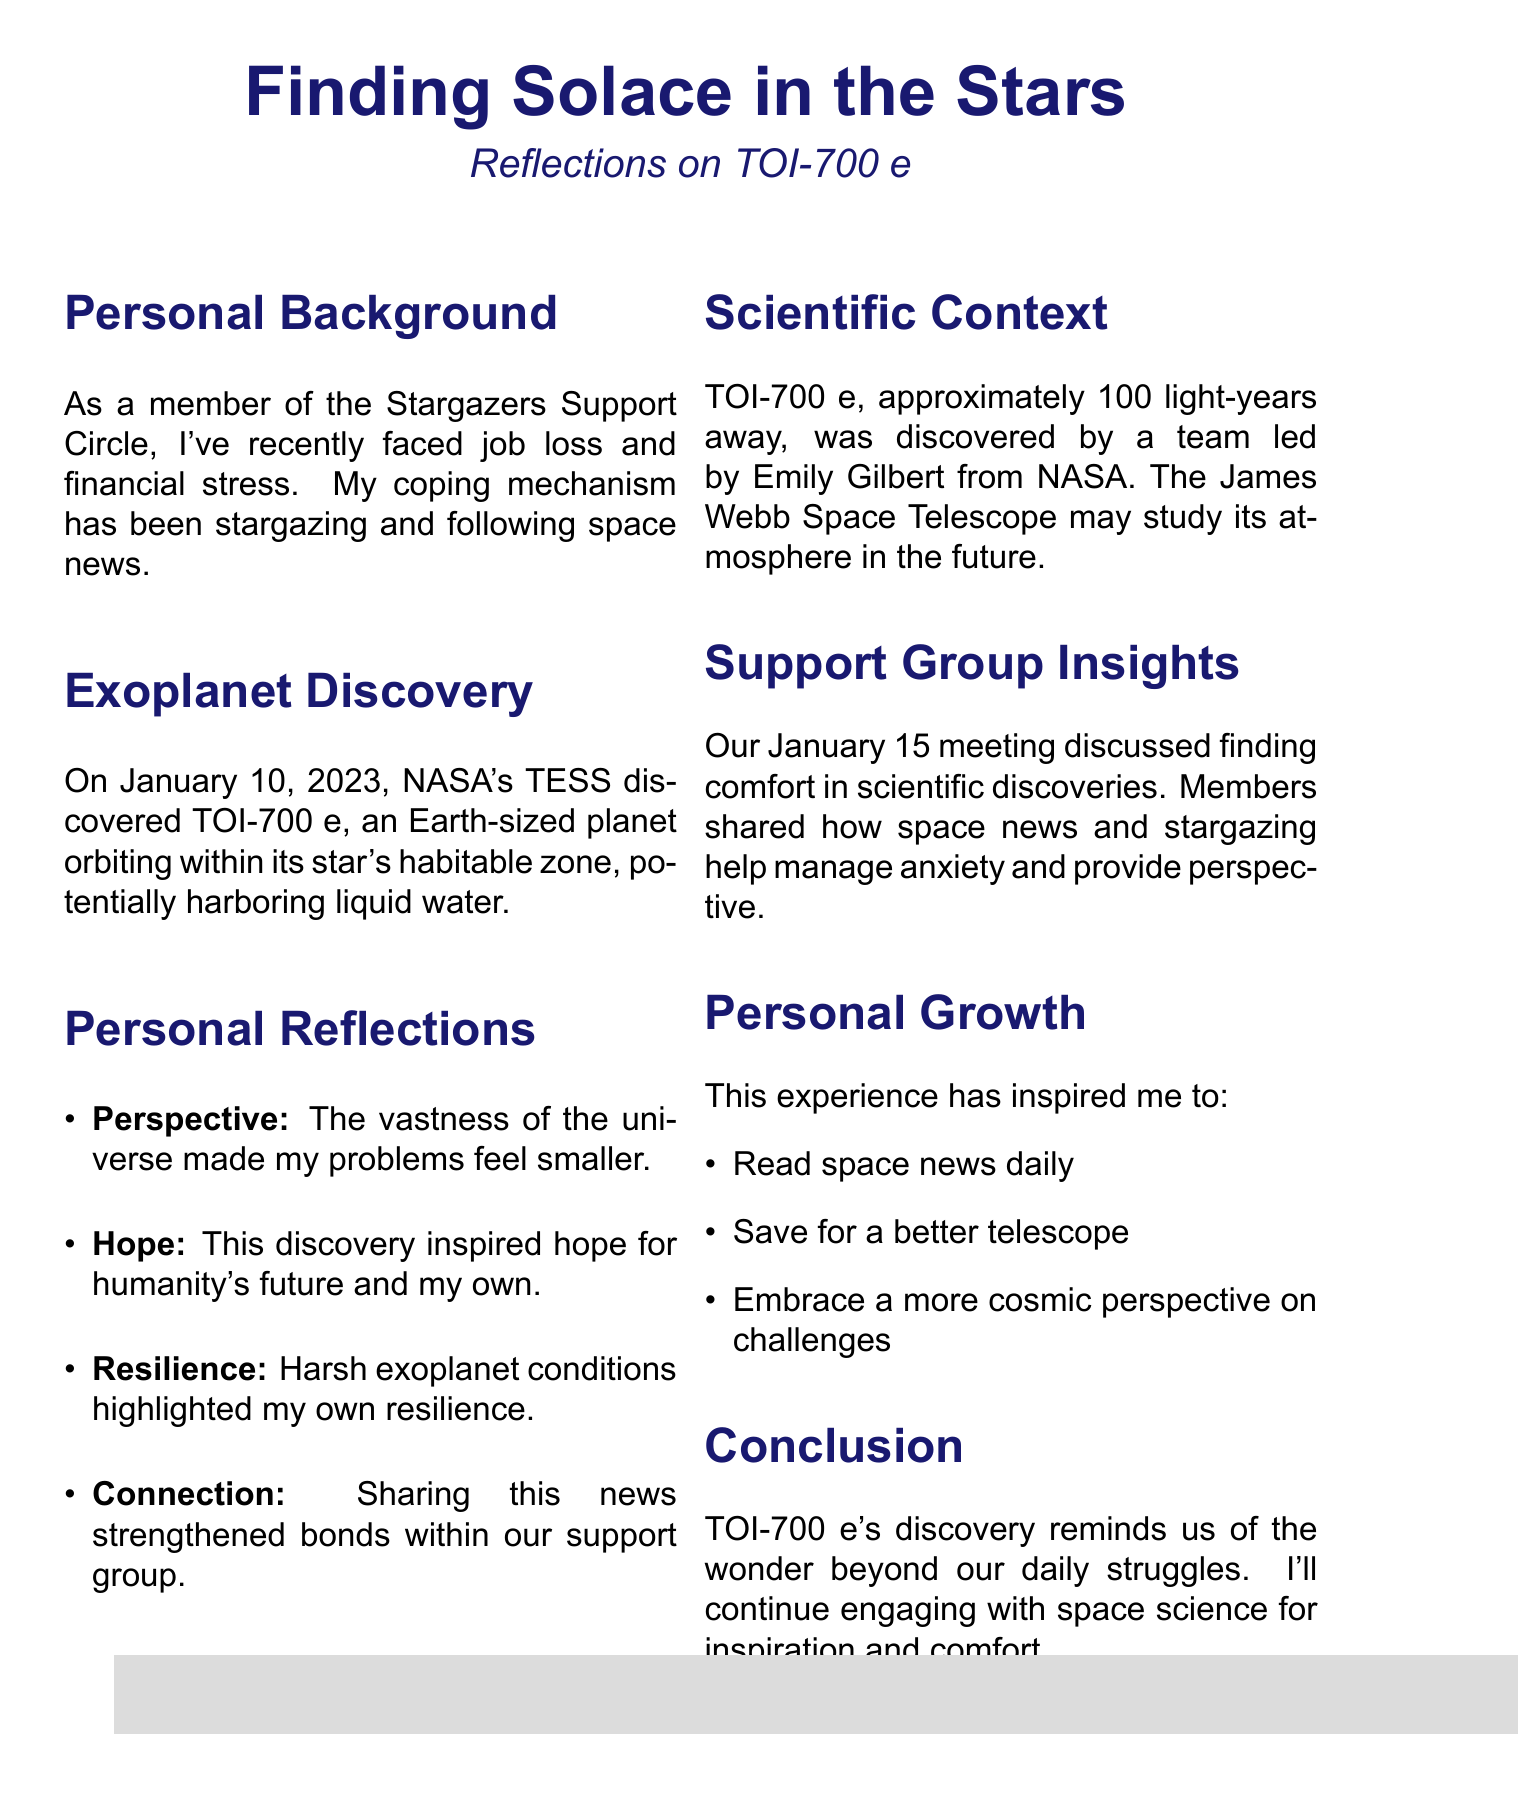what is the name of the exoplanet discussed? The exoplanet mentioned in the document is specifically named TOI-700 e.
Answer: TOI-700 e when was TOI-700 e discovered? The discovery date of TOI-700 e is stated in the document as January 10, 2023.
Answer: January 10, 2023 who led the research team that discovered TOI-700 e? The document names Emily Gilbert as the leader of the research team from NASA Goddard Space Flight Center.
Answer: Emily Gilbert what is the distance of TOI-700 e from Earth? The document specifies that TOI-700 e is approximately 100 light-years away from Earth.
Answer: Approximately 100 light-years what theme relates to feeling connected to others? The document references "Connection" as a theme reflecting the shared experience among group members related to space exploration.
Answer: Connection what coping mechanism did the author use during their recent challenges? The document states that the author's coping mechanism has been stargazing and following space news.
Answer: Stargazing and following space news what personal growth habit was adopted after learning about TOI-700 e? The document reveals that the author started a new habit of daily reading of space news from NASA and ESA websites.
Answer: Daily reading of space news which telescope may study TOI-700 e's atmosphere in the future? The document mentions the James Webb Space Telescope as the potential future instrument to study TOI-700 e's atmosphere.
Answer: James Webb Space Telescope what was a significant topic of discussion in the January 15 support group meeting? The document highlights the discussion topic as finding comfort in scientific discoveries among support group members.
Answer: Finding comfort in scientific discoveries 